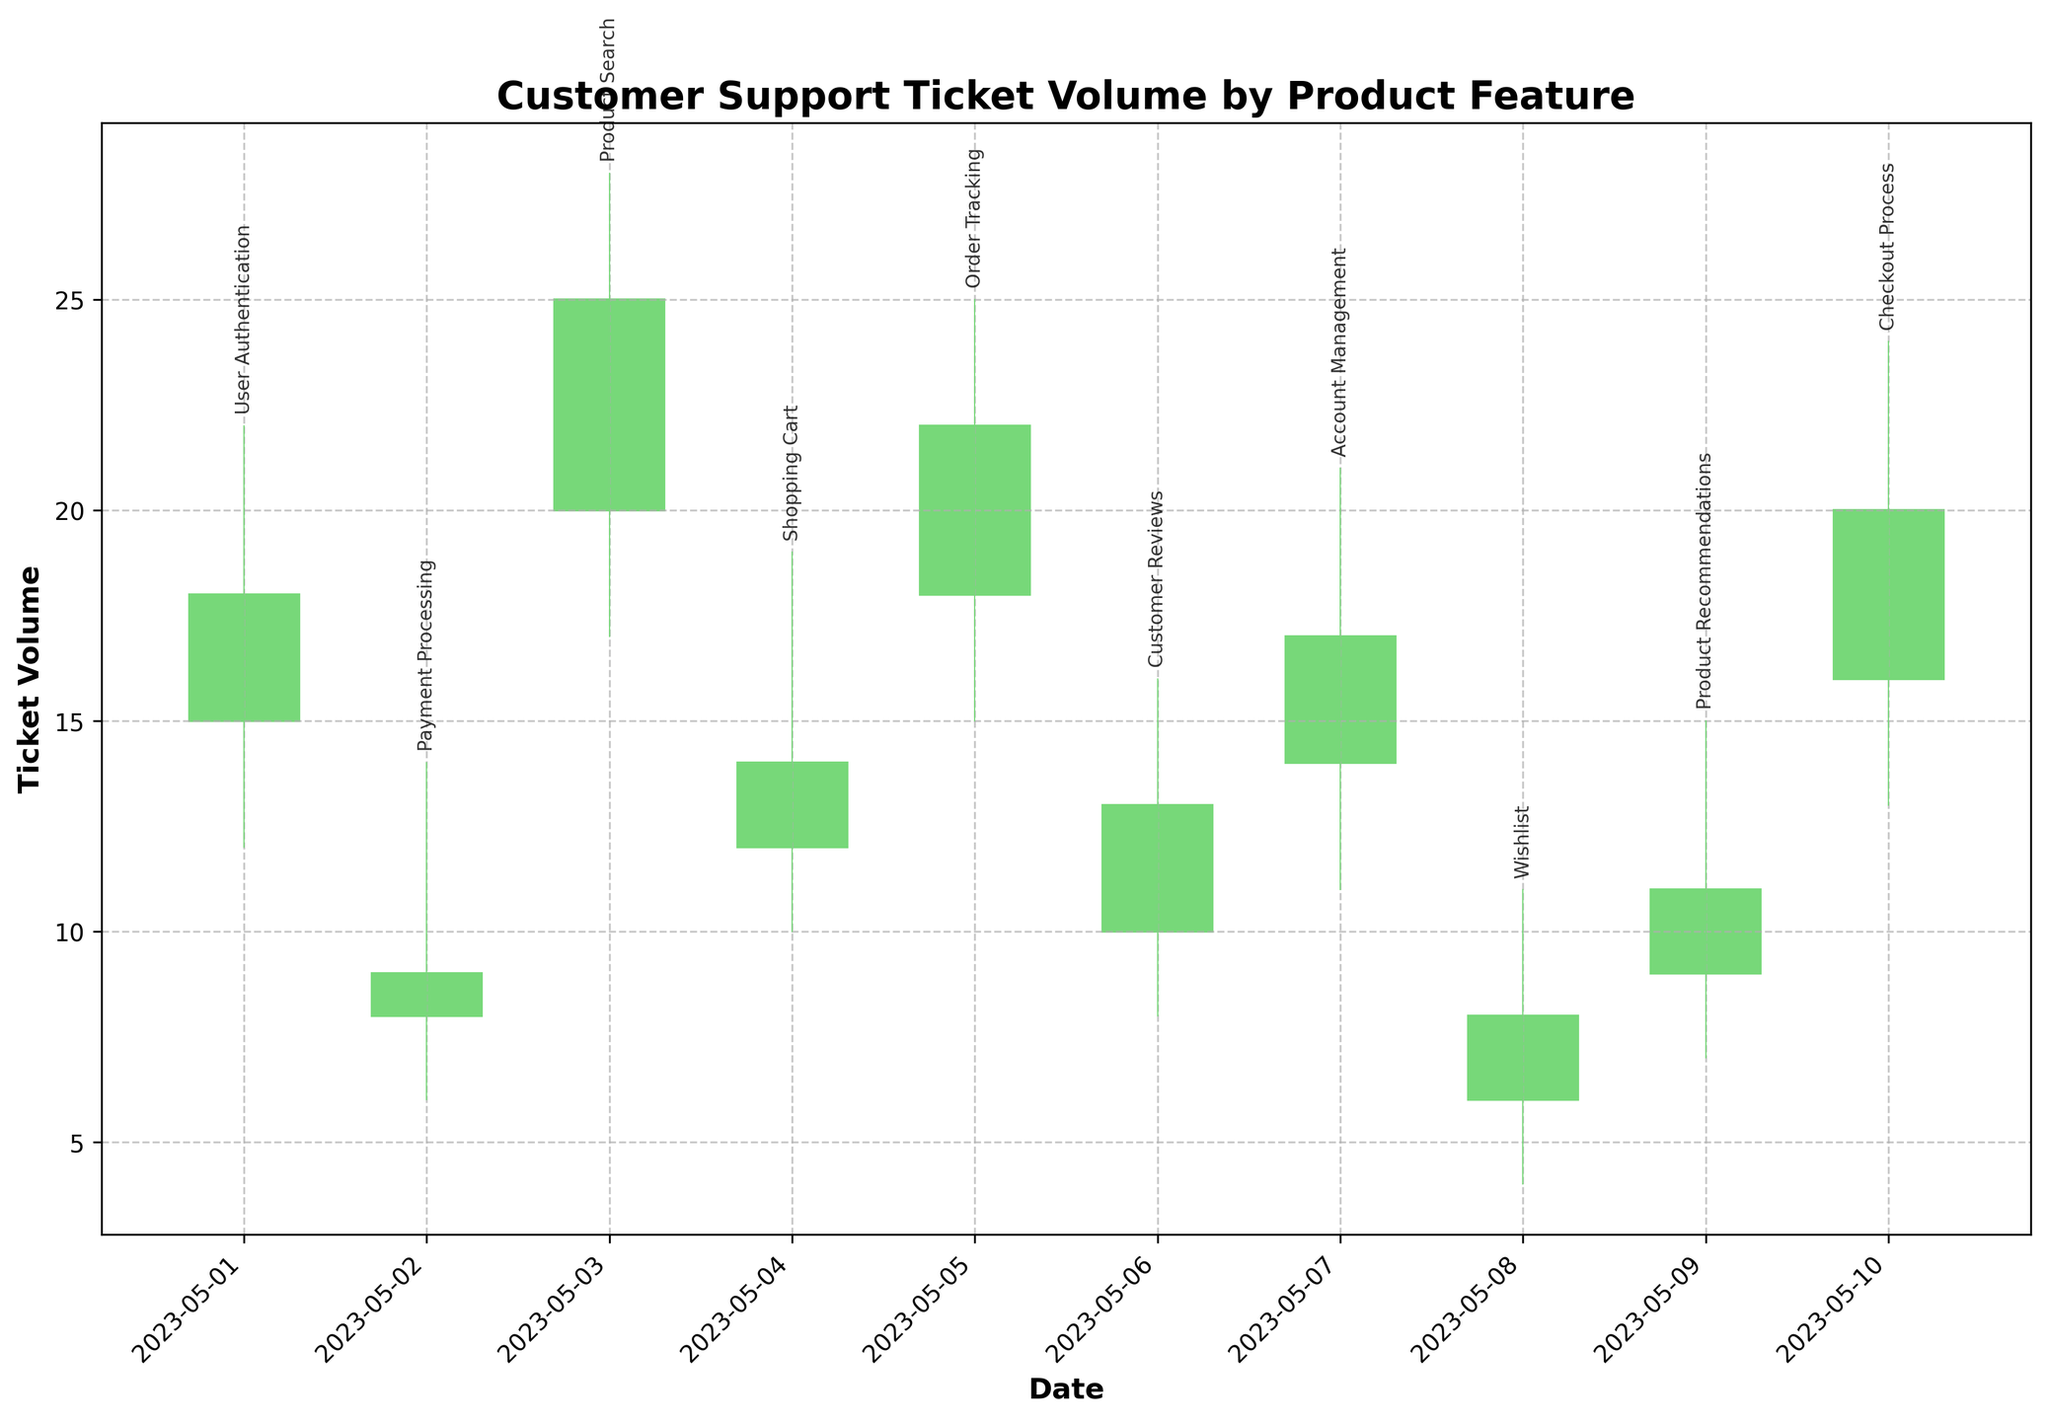What is the title of the chart? The title of the chart is typically found at the top of the figure. It provides context for understanding what the chart represents. In this case, the title is "Customer Support Ticket Volume by Product Feature".
Answer: Customer Support Ticket Volume by Product Feature How many dates are displayed on the x-axis? To determine this, count the distinct vertical lines or date labels along the x-axis. Each line or label represents a specific date.
Answer: 10 Which date had the highest ticket volume for the feature "User Authentication"? Look for the highest point (High) on the OHLC chart that corresponds to the dates and features. For "User Authentication" on 2023-05-01, the highest value is indicated.
Answer: 2023-05-01 What is the opening and closing ticket volume for "Payment Processing"? Find the bar that represents "Payment Processing" on the specified date (2023-05-02). The bottom and top points of the bar indicate the open and close volumes respectively. For "Payment Processing", the open volume is 8 and the close volume is 9.
Answer: Open: 8, Close: 9 Which feature experienced the largest difference between high and low ticket volumes, and what is that difference? To find this, calculate the difference between the high and low values for each feature and date. The largest difference will give the correct feature and difference. For instance, "Product Search" on 2023-05-03 has a high of 28 and a low of 17, resulting in the largest difference of 11.
Answer: Product Search, 11 Across all features, which date had the highest closing ticket volume? Determine the closing ticket volume of each feature on their corresponding dates and identify the maximum closing value. The highest closing ticket volume is on 2023-05-03 for "Product Search", which is 25.
Answer: 2023-05-03 What is the total ticket volume reported for "Order Tracking" from open to close? Add the open and close volumes for the "Order Tracking" feature to get the total ticket volume. The open volume is 18 and the close volume is 22, making the total 40.
Answer: 40 Which feature had the lowest ticket volume close value during the observed period? Review the closing values for each feature and date to determine the minimum value. For the dataset, "Wishlist" on 2023-05-08 has the lowest closing volume of 8.
Answer: Wishlist How does the highest ticket volume for "Checkout Process" compare to the highest volume of "User Authentication"? Compare the high values of "Checkout Process" on 2023-05-10 and "User Authentication" on 2023-05-01. "Checkout Process" has a high of 24 and "User Authentication" has a high of 22. The highest volume of "Checkout Process" is greater than "User Authentication".
Answer: Checkout Process > User Authentication (24 > 22) What are the low ticket volumes for "Customer Reviews" and "Account Management" and how do they compare? Examine the low values for "Customer Reviews" on 2023-05-06 and "Account Management" on 2023-05-07. "Customer Reviews" has a low of 8 and "Account Management" has a low of 11. "Customer Reviews" has the lower volume.
Answer: Customer Reviews: 8, Account Management: 11, Customer Reviews < Account Management 